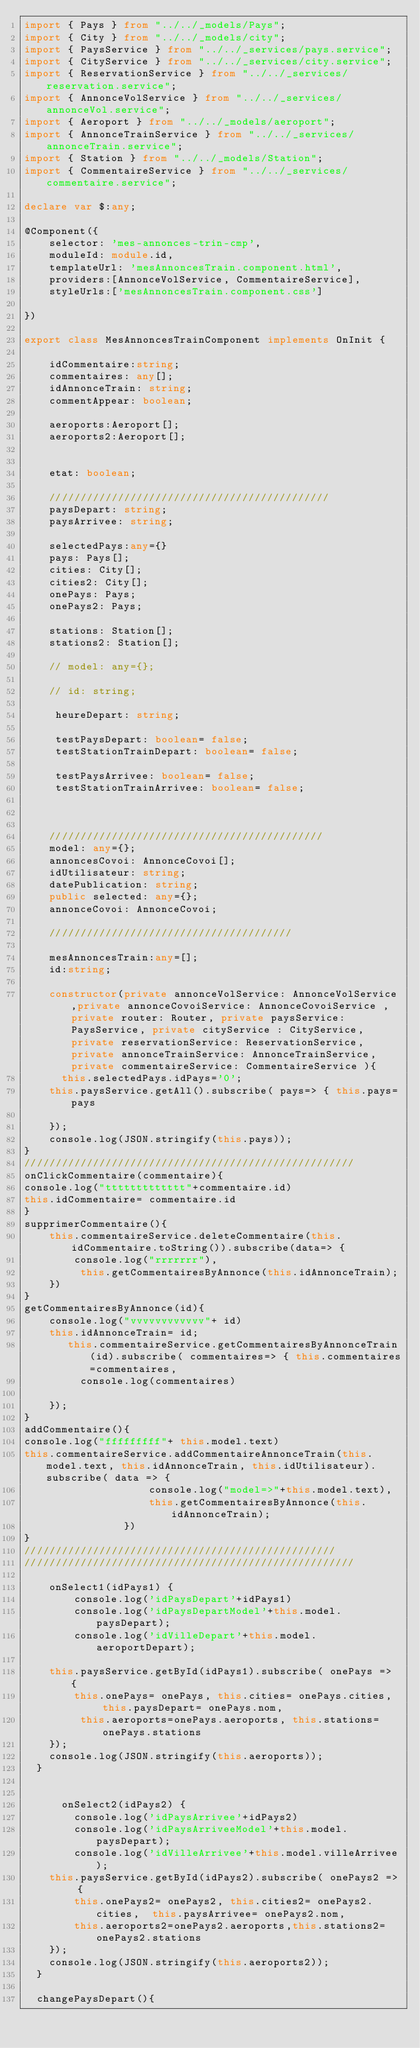Convert code to text. <code><loc_0><loc_0><loc_500><loc_500><_TypeScript_>import { Pays } from "../../_models/Pays";
import { City } from "../../_models/city";
import { PaysService } from "../../_services/pays.service";
import { CityService } from "../../_services/city.service";
import { ReservationService } from "../../_services/reservation.service";
import { AnnonceVolService } from "../../_services/annonceVol.service";
import { Aeroport } from "../../_models/aeroport";
import { AnnonceTrainService } from "../../_services/annonceTrain.service";
import { Station } from "../../_models/Station";
import { CommentaireService } from "../../_services/commentaire.service";

declare var $:any;

@Component({
    selector: 'mes-annonces-trin-cmp',
    moduleId: module.id,
    templateUrl: 'mesAnnoncesTrain.component.html',
    providers:[AnnonceVolService, CommentaireService],
    styleUrls:['mesAnnoncesTrain.component.css']

})

export class MesAnnoncesTrainComponent implements OnInit {
    
    idCommentaire:string;
    commentaires: any[];
    idAnnonceTrain: string;
    commentAppear: boolean;

    aeroports:Aeroport[];
    aeroports2:Aeroport[];
    

    etat: boolean;

    /////////////////////////////////////////////
    paysDepart: string;
    paysArrivee: string;

    selectedPays:any={}
    pays: Pays[];
    cities: City[];
    cities2: City[];
    onePays: Pays;
    onePays2: Pays;

    stations: Station[];
    stations2: Station[];

    // model: any={};

    // id: string;

     heureDepart: string;

     testPaysDepart: boolean= false;
     testStationTrainDepart: boolean= false;

     testPaysArrivee: boolean= false;
     testStationTrainArrivee: boolean= false;

     

    ////////////////////////////////////////////
    model: any={};
    annoncesCovoi: AnnonceCovoi[];
    idUtilisateur: string;
    datePublication: string;
    public selected: any={};
    annonceCovoi: AnnonceCovoi;

    ///////////////////////////////////////

    mesAnnoncesTrain:any=[];
    id:string;

    constructor(private annonceVolService: AnnonceVolService,private annonceCovoiService: AnnonceCovoiService , private router: Router, private paysService: PaysService, private cityService : CityService, private reservationService: ReservationService, private annonceTrainService: AnnonceTrainService, private commentaireService: CommentaireService ){
      this.selectedPays.idPays='0';
    this.paysService.getAll().subscribe( pays=> { this.pays=pays 
    
    });
    console.log(JSON.stringify(this.pays));   
}
/////////////////////////////////////////////////////
onClickCommentaire(commentaire){
console.log("ttttttttttttt"+commentaire.id)
this.idCommentaire= commentaire.id
}
supprimerCommentaire(){
    this.commentaireService.deleteCommentaire(this.idCommentaire.toString()).subscribe(data=> {
        console.log("rrrrrrr"),
         this.getCommentairesByAnnonce(this.idAnnonceTrain);
    })
}
getCommentairesByAnnonce(id){
    console.log("vvvvvvvvvvvv"+ id)
    this.idAnnonceTrain= id;
       this.commentaireService.getCommentairesByAnnonceTrain(id).subscribe( commentaires=> { this.commentaires=commentaires,
         console.log(commentaires)
        
    });
}
addCommentaire(){
console.log("fffffffff"+ this.model.text)
this.commentaireService.addCommentaireAnnonceTrain(this.model.text, this.idAnnonceTrain, this.idUtilisateur).subscribe( data => { 
                    console.log("model=>"+this.model.text),
                    this.getCommentairesByAnnonce(this.idAnnonceTrain);
                })
}
//////////////////////////////////////////////////
/////////////////////////////////////////////////////

    onSelect1(idPays1) {
        console.log('idPaysDepart'+idPays1)
        console.log('idPaysDepartModel'+this.model.paysDepart);
        console.log('idVilleDepart'+this.model.aeroportDepart);
        
    this.paysService.getById(idPays1).subscribe( onePays => {
        this.onePays= onePays, this.cities= onePays.cities,  this.paysDepart= onePays.nom,
         this.aeroports=onePays.aeroports, this.stations= onePays.stations
    });
    console.log(JSON.stringify(this.aeroports));
  }


      onSelect2(idPays2) {
        console.log('idPaysArrivee'+idPays2)
        console.log('idPaysArriveeModel'+this.model.paysDepart);
        console.log('idVilleArrivee'+this.model.villeArrivee);
    this.paysService.getById(idPays2).subscribe( onePays2 => {
        this.onePays2= onePays2, this.cities2= onePays2.cities,  this.paysArrivee= onePays2.nom,
        this.aeroports2=onePays2.aeroports,this.stations2= onePays2.stations
    });
    console.log(JSON.stringify(this.aeroports2));
  }

  changePaysDepart(){</code> 